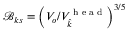Convert formula to latex. <formula><loc_0><loc_0><loc_500><loc_500>\mathcal { B } _ { k s } = \left ( V _ { o } / V _ { \widehat { k } } ^ { h e a d } \right ) ^ { 3 / 5 }</formula> 